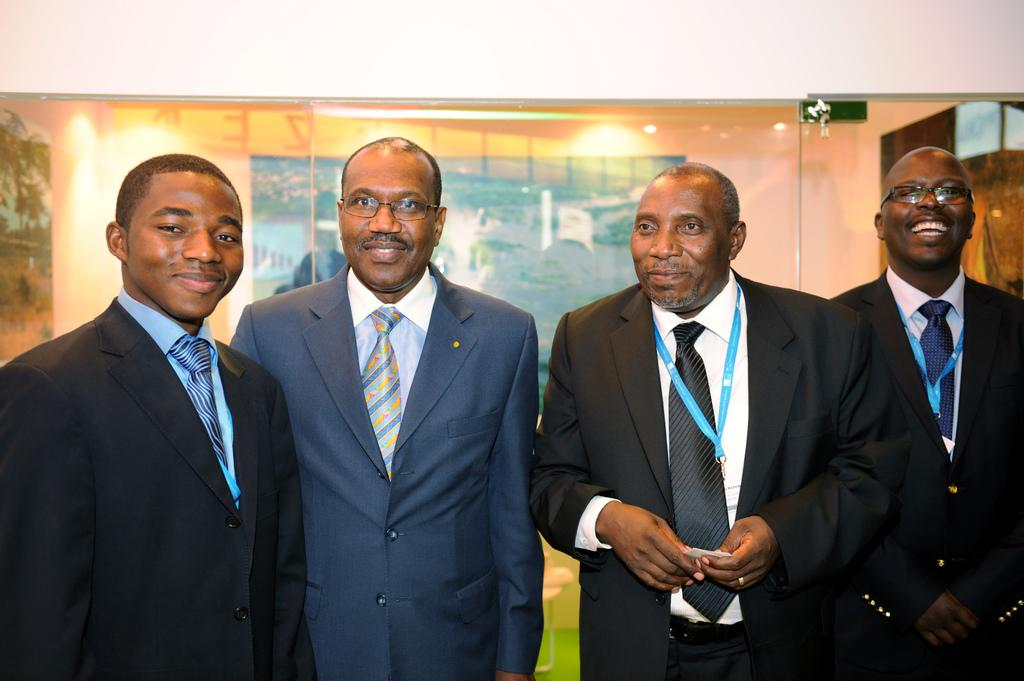What are the people in the image wearing? The people in the image are wearing jackets. What can be seen in the background of the image? There is a wall and lights visible in the background of the image. What type of stem can be seen growing from the wall in the image? There is no stem growing from the wall in the image. What year does the image depict? The image does not depict a specific year, as it is a photograph or illustration of a scene. 